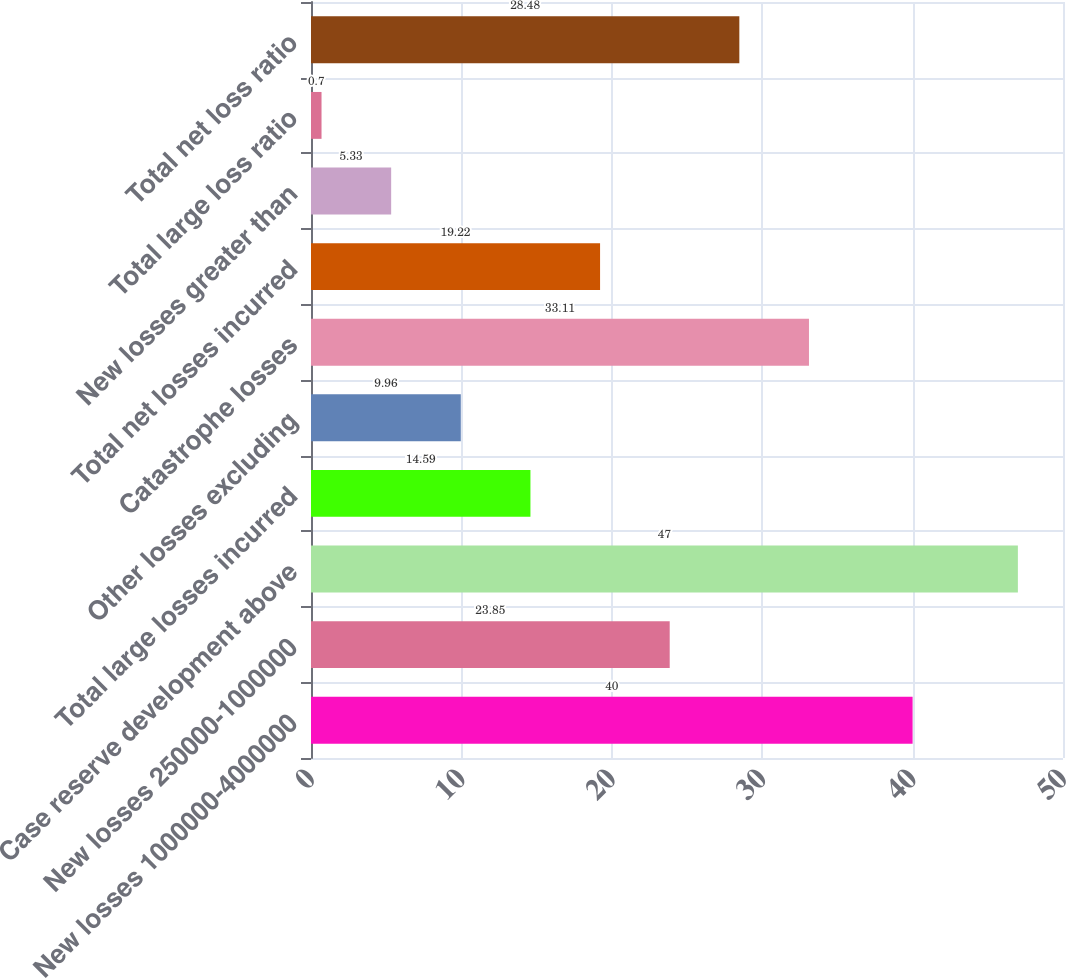Convert chart to OTSL. <chart><loc_0><loc_0><loc_500><loc_500><bar_chart><fcel>New losses 1000000-4000000<fcel>New losses 250000-1000000<fcel>Case reserve development above<fcel>Total large losses incurred<fcel>Other losses excluding<fcel>Catastrophe losses<fcel>Total net losses incurred<fcel>New losses greater than<fcel>Total large loss ratio<fcel>Total net loss ratio<nl><fcel>40<fcel>23.85<fcel>47<fcel>14.59<fcel>9.96<fcel>33.11<fcel>19.22<fcel>5.33<fcel>0.7<fcel>28.48<nl></chart> 